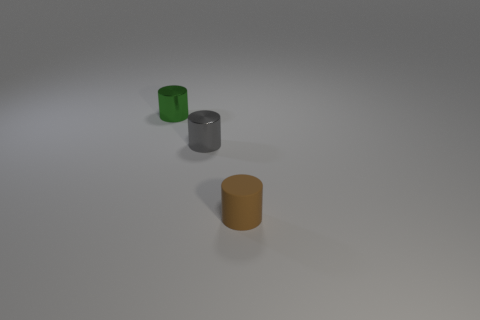How many things are tiny green cylinders or tiny cyan cubes?
Offer a terse response. 1. Are any tiny brown matte cylinders visible?
Ensure brevity in your answer.  Yes. Is the number of tiny blue metal blocks less than the number of small objects?
Make the answer very short. Yes. Are there any purple rubber things that have the same size as the brown matte cylinder?
Your answer should be very brief. No. Do the tiny brown matte thing and the small metallic thing in front of the green metallic object have the same shape?
Give a very brief answer. Yes. How many balls are gray shiny things or small green metallic things?
Provide a short and direct response. 0. What is the color of the tiny matte thing?
Ensure brevity in your answer.  Brown. Are there more tiny green matte cubes than tiny brown things?
Make the answer very short. No. How many objects are green metallic things that are behind the tiny gray thing or small green things?
Offer a terse response. 1. Is the material of the green cylinder the same as the gray cylinder?
Give a very brief answer. Yes. 